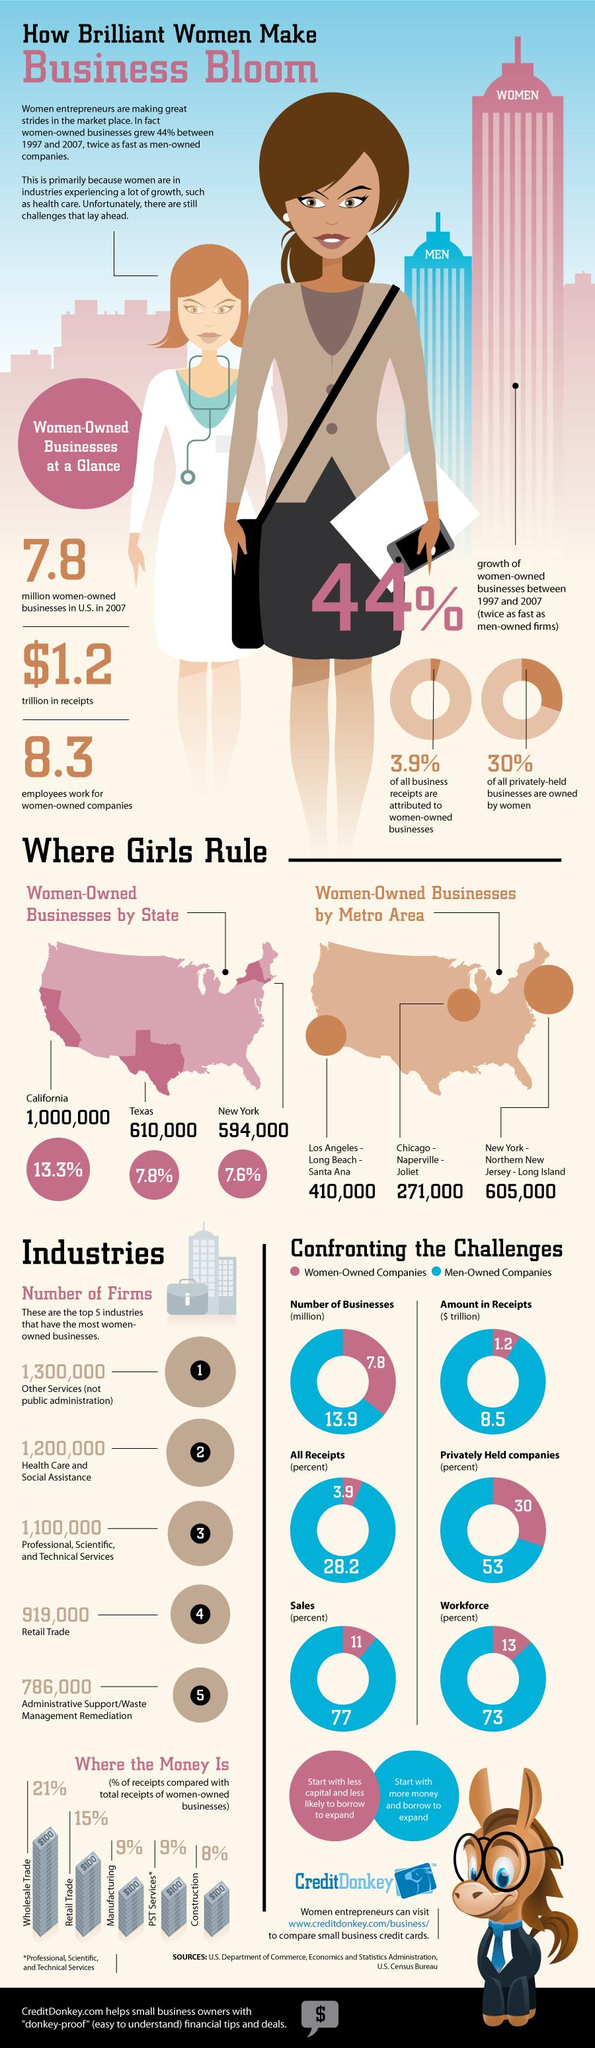Highlight a few significant elements in this photo. In the top 5 industries with the most women-owned businesses, Retail Trade is the top fourth industry that ranks the most. According to the data, there are 6.1 million men-owned companies, while there are only 0.2 million women-owned companies. New York has the third highest number of women-owned businesses, according to recent data. Professional, Scientific, and Technical Services is the third industry among the top 5 that has the most women-owned businesses. According to a recent study, approximately 30% of privately held companies in the United States are owned by women. 